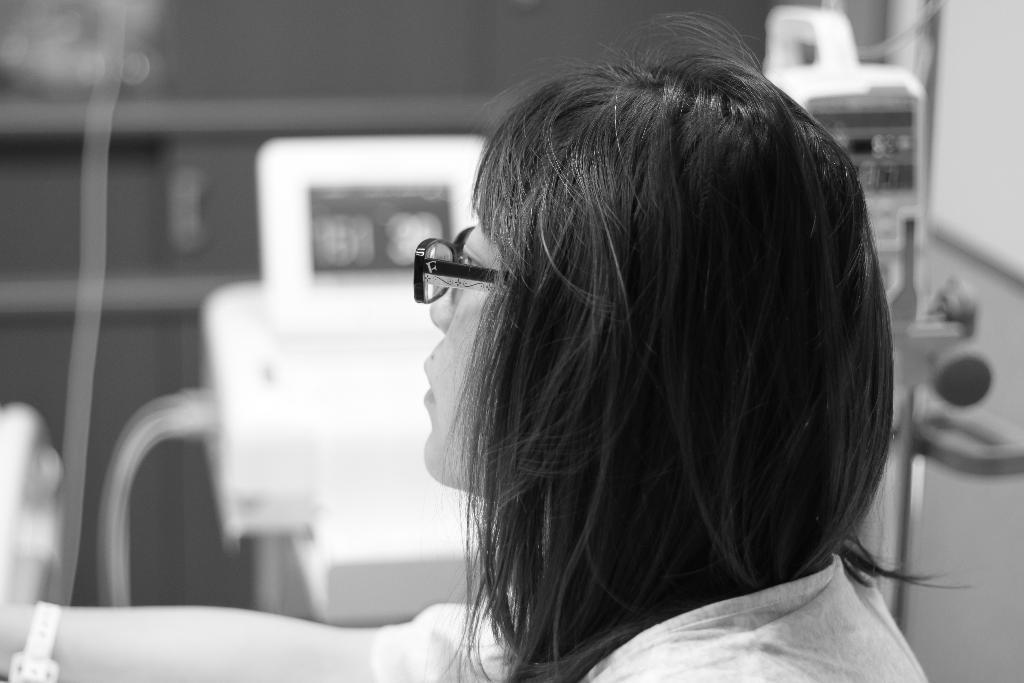How would you summarize this image in a sentence or two? In this picture there is a girl on the right side of the image and there is machinery in the background area of the image. 